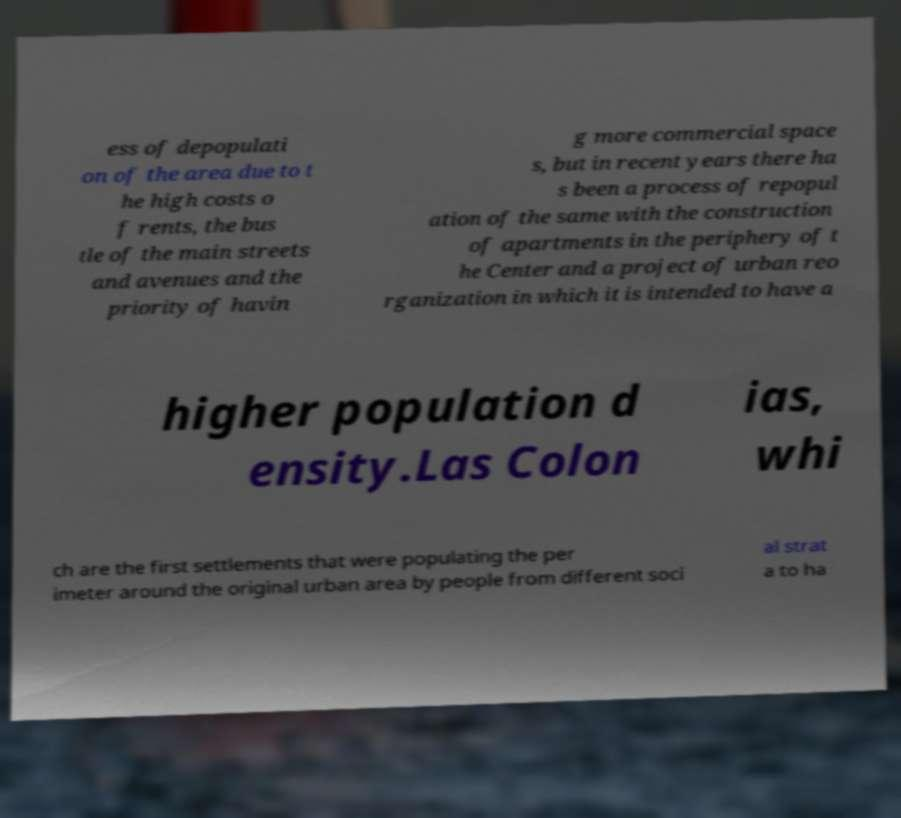Can you read and provide the text displayed in the image?This photo seems to have some interesting text. Can you extract and type it out for me? ess of depopulati on of the area due to t he high costs o f rents, the bus tle of the main streets and avenues and the priority of havin g more commercial space s, but in recent years there ha s been a process of repopul ation of the same with the construction of apartments in the periphery of t he Center and a project of urban reo rganization in which it is intended to have a higher population d ensity.Las Colon ias, whi ch are the first settlements that were populating the per imeter around the original urban area by people from different soci al strat a to ha 